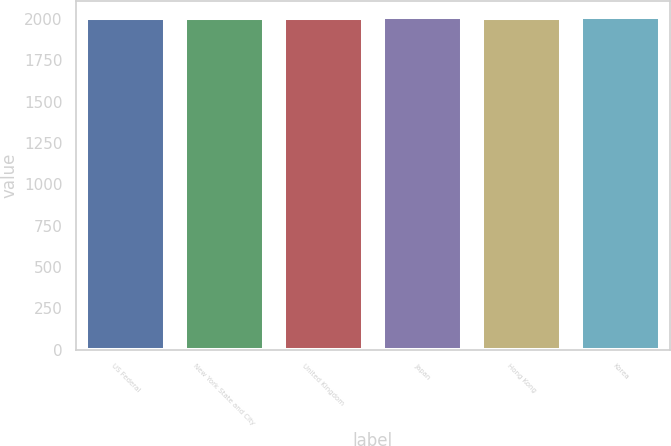Convert chart. <chart><loc_0><loc_0><loc_500><loc_500><bar_chart><fcel>US Federal<fcel>New York State and City<fcel>United Kingdom<fcel>Japan<fcel>Hong Kong<fcel>Korea<nl><fcel>2008<fcel>2004<fcel>2008.6<fcel>2010<fcel>2006<fcel>2010.6<nl></chart> 